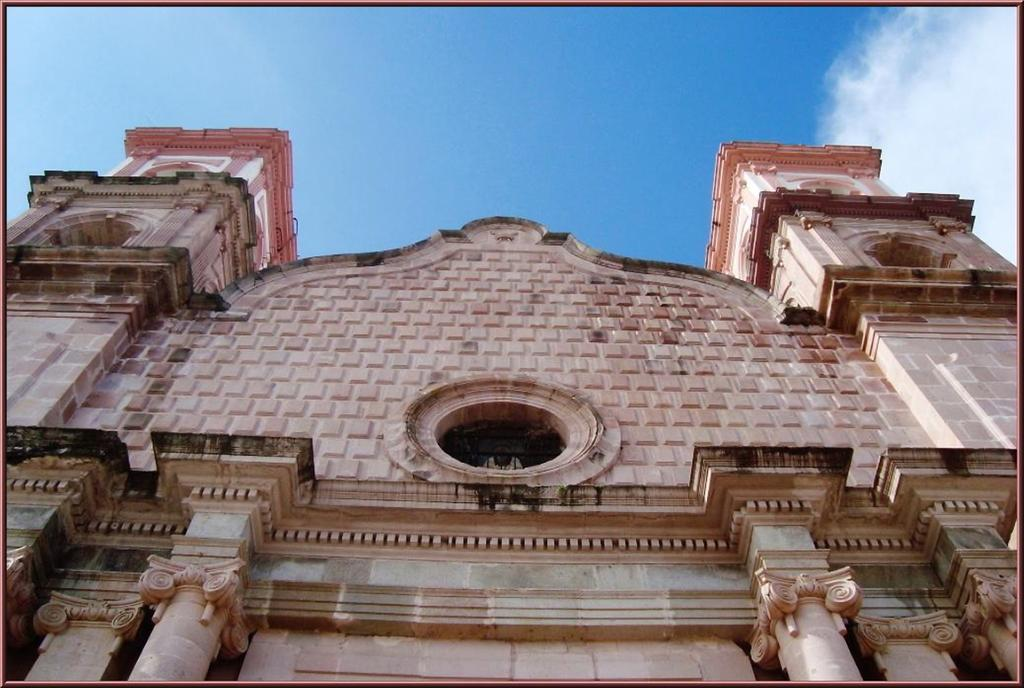What type of structure is present in the image? There is a building in the image. What can be seen above the building in the image? The sky is visible at the top of the image. How many legs does the building have in the image? Buildings do not have legs; they are stationary structures. 